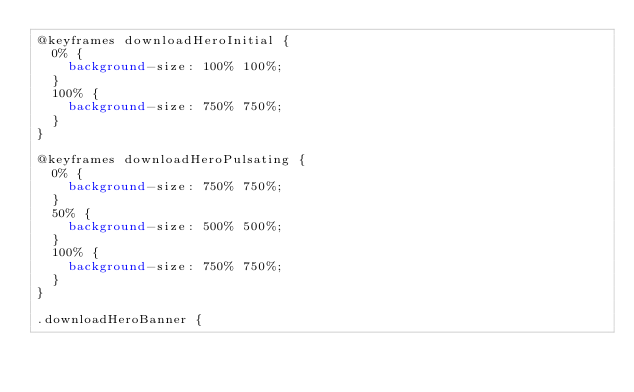<code> <loc_0><loc_0><loc_500><loc_500><_CSS_>@keyframes downloadHeroInitial {
  0% {
    background-size: 100% 100%;
  }
  100% {
    background-size: 750% 750%;
  }
}

@keyframes downloadHeroPulsating {
  0% {
    background-size: 750% 750%;
  }
  50% {
    background-size: 500% 500%;
  }
  100% {
    background-size: 750% 750%;
  }
}

.downloadHeroBanner {</code> 